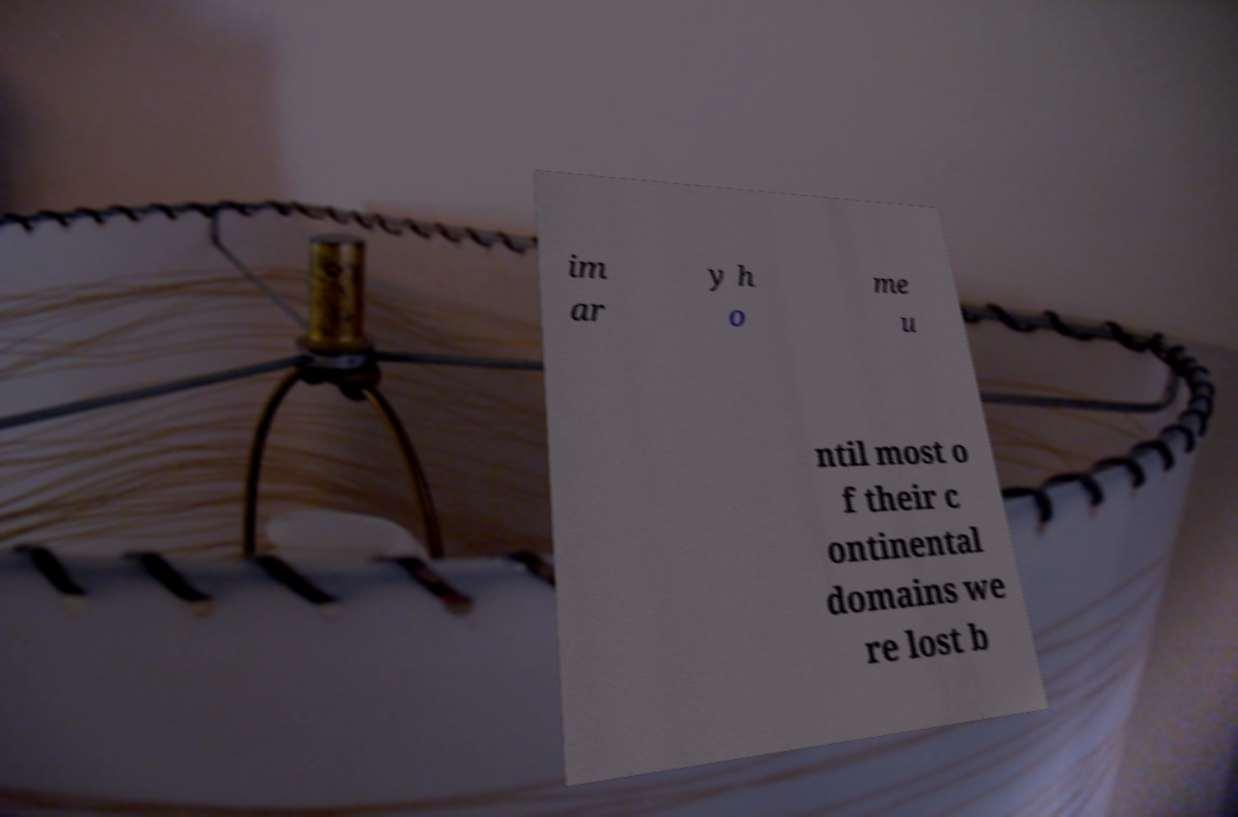Could you assist in decoding the text presented in this image and type it out clearly? im ar y h o me u ntil most o f their c ontinental domains we re lost b 